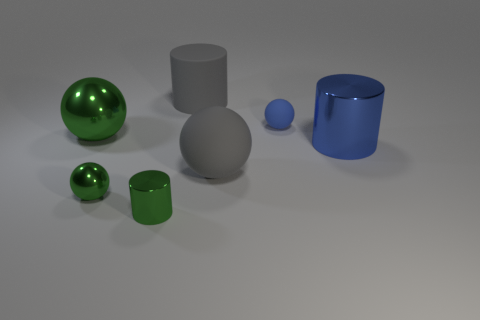Subtract all cyan balls. Subtract all gray cylinders. How many balls are left? 4 Add 3 yellow metal balls. How many objects exist? 10 Subtract all balls. How many objects are left? 3 Add 6 tiny metallic balls. How many tiny metallic balls are left? 7 Add 3 large gray matte objects. How many large gray matte objects exist? 5 Subtract 0 cyan cubes. How many objects are left? 7 Subtract all red shiny cylinders. Subtract all gray rubber cylinders. How many objects are left? 6 